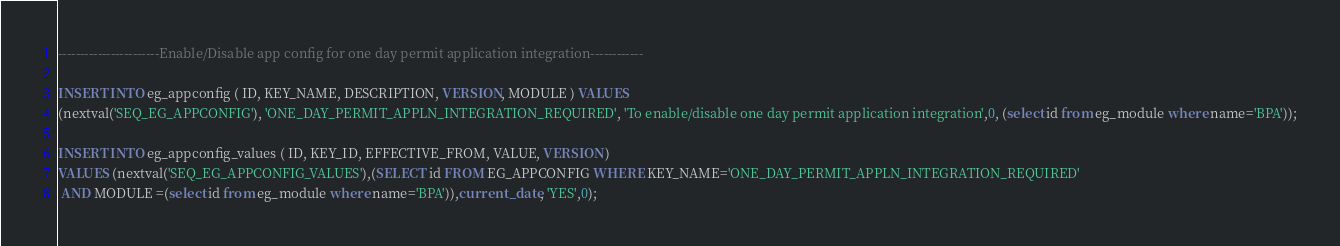Convert code to text. <code><loc_0><loc_0><loc_500><loc_500><_SQL_>-----------------------Enable/Disable app config for one day permit application integration------------

INSERT INTO eg_appconfig ( ID, KEY_NAME, DESCRIPTION, VERSION, MODULE ) VALUES
(nextval('SEQ_EG_APPCONFIG'), 'ONE_DAY_PERMIT_APPLN_INTEGRATION_REQUIRED', 'To enable/disable one day permit application integration',0, (select id from eg_module where name='BPA'));

INSERT INTO eg_appconfig_values ( ID, KEY_ID, EFFECTIVE_FROM, VALUE, VERSION )
VALUES (nextval('SEQ_EG_APPCONFIG_VALUES'),(SELECT id FROM EG_APPCONFIG WHERE KEY_NAME='ONE_DAY_PERMIT_APPLN_INTEGRATION_REQUIRED'
 AND MODULE =(select id from eg_module where name='BPA')),current_date, 'YES',0);
</code> 